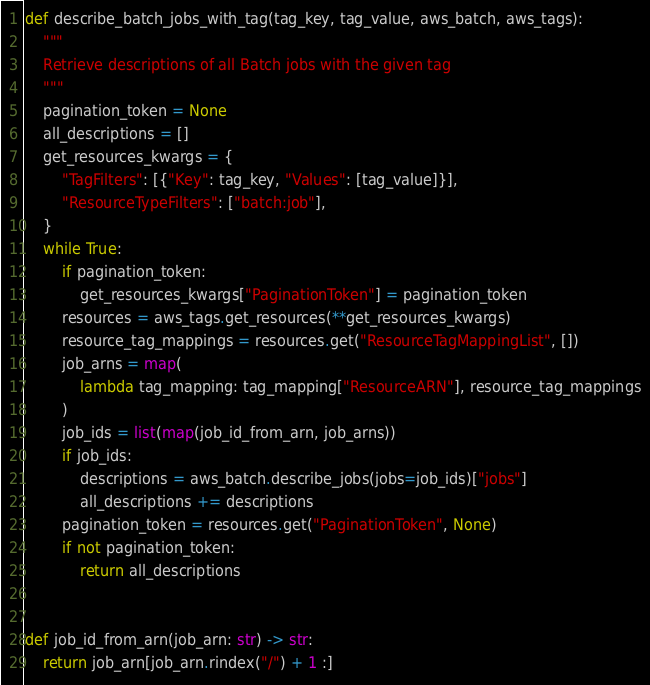<code> <loc_0><loc_0><loc_500><loc_500><_Python_>def describe_batch_jobs_with_tag(tag_key, tag_value, aws_batch, aws_tags):
    """
    Retrieve descriptions of all Batch jobs with the given tag
    """
    pagination_token = None
    all_descriptions = []
    get_resources_kwargs = {
        "TagFilters": [{"Key": tag_key, "Values": [tag_value]}],
        "ResourceTypeFilters": ["batch:job"],
    }
    while True:
        if pagination_token:
            get_resources_kwargs["PaginationToken"] = pagination_token
        resources = aws_tags.get_resources(**get_resources_kwargs)
        resource_tag_mappings = resources.get("ResourceTagMappingList", [])
        job_arns = map(
            lambda tag_mapping: tag_mapping["ResourceARN"], resource_tag_mappings
        )
        job_ids = list(map(job_id_from_arn, job_arns))
        if job_ids:
            descriptions = aws_batch.describe_jobs(jobs=job_ids)["jobs"]
            all_descriptions += descriptions
        pagination_token = resources.get("PaginationToken", None)
        if not pagination_token:
            return all_descriptions


def job_id_from_arn(job_arn: str) -> str:
    return job_arn[job_arn.rindex("/") + 1 :]
</code> 